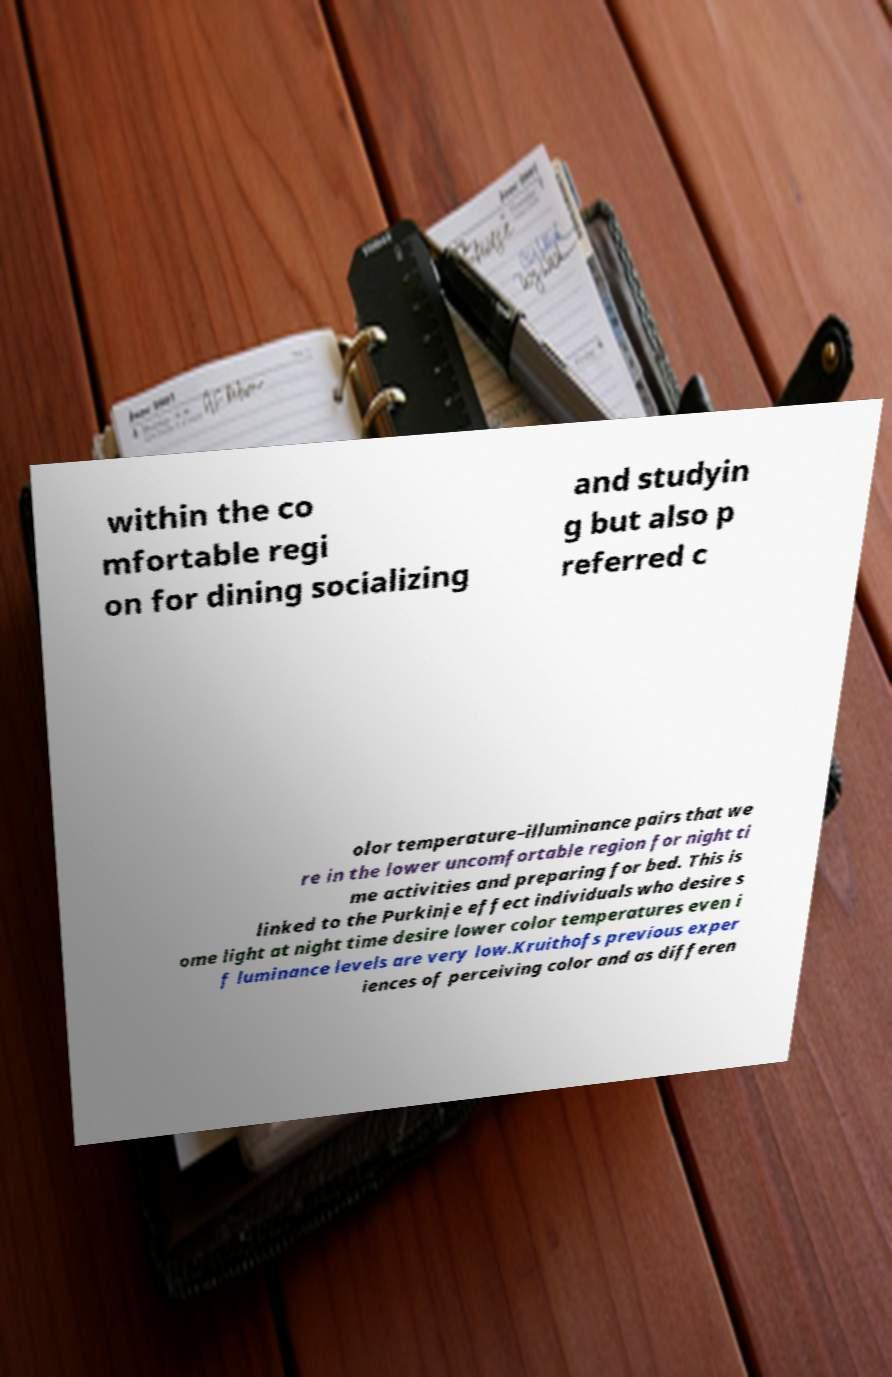Can you read and provide the text displayed in the image?This photo seems to have some interesting text. Can you extract and type it out for me? within the co mfortable regi on for dining socializing and studyin g but also p referred c olor temperature–illuminance pairs that we re in the lower uncomfortable region for night ti me activities and preparing for bed. This is linked to the Purkinje effect individuals who desire s ome light at night time desire lower color temperatures even i f luminance levels are very low.Kruithofs previous exper iences of perceiving color and as differen 